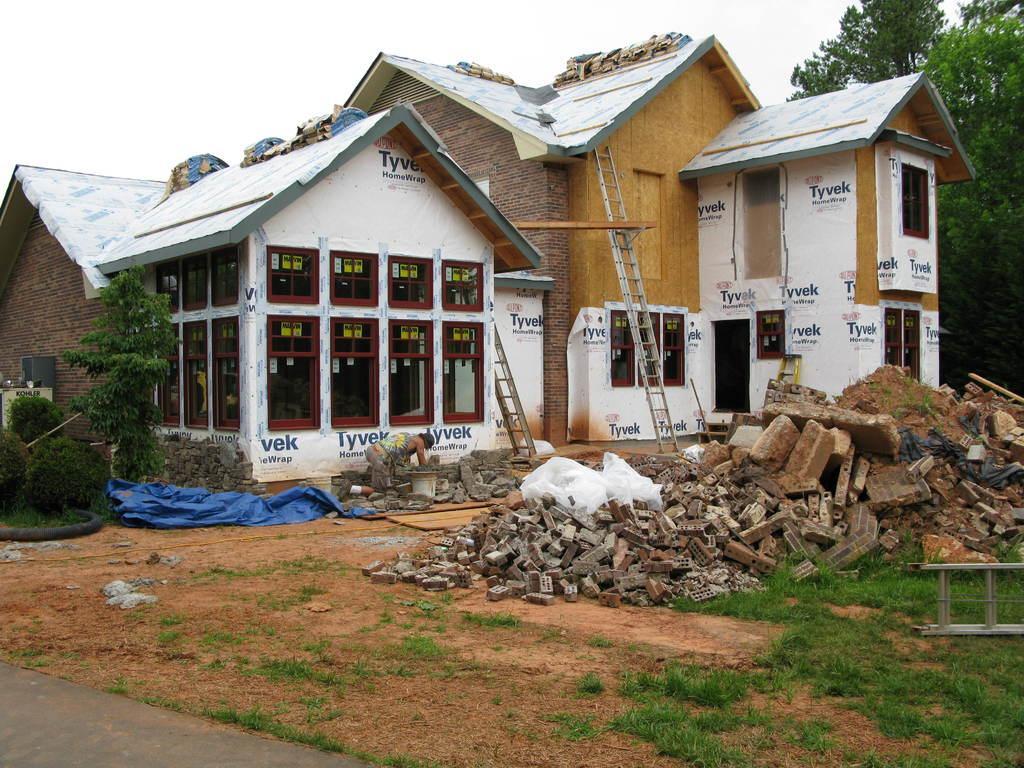In one or two sentences, can you explain what this image depicts? In this picture I can see buildings, ladders and some objects on the ground. I can also see grass, plants, trees and the sky in the background. Here I can see some blue color object and windows. 